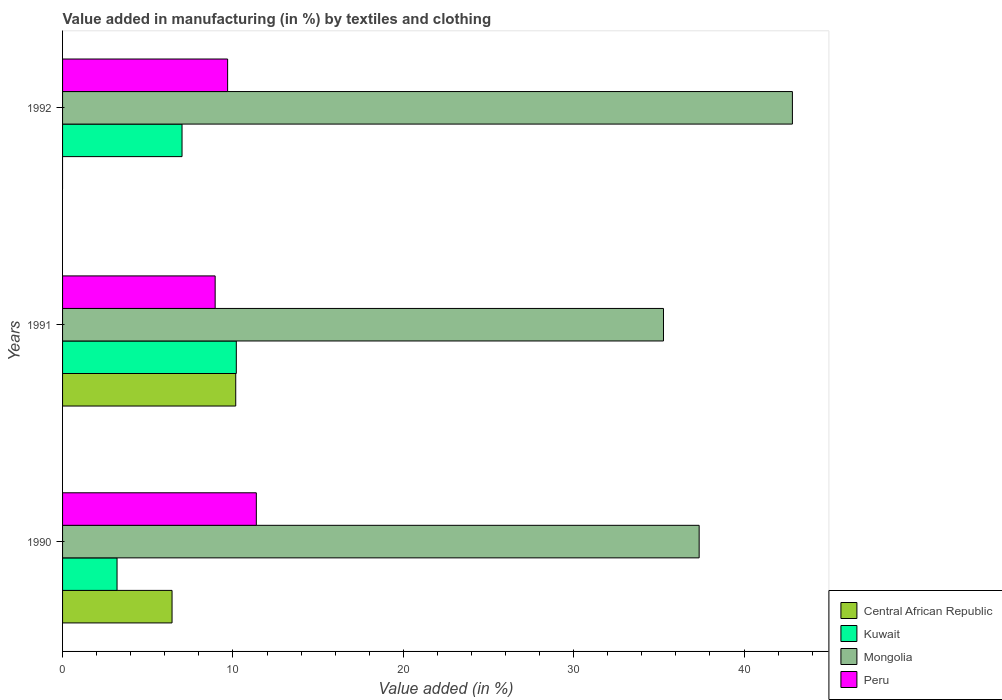How many groups of bars are there?
Your response must be concise. 3. Are the number of bars per tick equal to the number of legend labels?
Keep it short and to the point. No. How many bars are there on the 3rd tick from the bottom?
Ensure brevity in your answer.  3. What is the label of the 1st group of bars from the top?
Offer a terse response. 1992. In how many cases, is the number of bars for a given year not equal to the number of legend labels?
Make the answer very short. 1. What is the percentage of value added in manufacturing by textiles and clothing in Kuwait in 1990?
Provide a short and direct response. 3.2. Across all years, what is the maximum percentage of value added in manufacturing by textiles and clothing in Mongolia?
Offer a very short reply. 42.84. Across all years, what is the minimum percentage of value added in manufacturing by textiles and clothing in Central African Republic?
Your answer should be very brief. 0. In which year was the percentage of value added in manufacturing by textiles and clothing in Kuwait maximum?
Provide a short and direct response. 1991. What is the total percentage of value added in manufacturing by textiles and clothing in Peru in the graph?
Provide a short and direct response. 30.02. What is the difference between the percentage of value added in manufacturing by textiles and clothing in Peru in 1990 and that in 1991?
Offer a terse response. 2.42. What is the difference between the percentage of value added in manufacturing by textiles and clothing in Mongolia in 1992 and the percentage of value added in manufacturing by textiles and clothing in Central African Republic in 1991?
Your answer should be compact. 32.68. What is the average percentage of value added in manufacturing by textiles and clothing in Mongolia per year?
Provide a short and direct response. 38.49. In the year 1990, what is the difference between the percentage of value added in manufacturing by textiles and clothing in Central African Republic and percentage of value added in manufacturing by textiles and clothing in Kuwait?
Your response must be concise. 3.23. What is the ratio of the percentage of value added in manufacturing by textiles and clothing in Peru in 1991 to that in 1992?
Provide a short and direct response. 0.92. Is the percentage of value added in manufacturing by textiles and clothing in Peru in 1990 less than that in 1992?
Ensure brevity in your answer.  No. Is the difference between the percentage of value added in manufacturing by textiles and clothing in Central African Republic in 1990 and 1991 greater than the difference between the percentage of value added in manufacturing by textiles and clothing in Kuwait in 1990 and 1991?
Your response must be concise. Yes. What is the difference between the highest and the second highest percentage of value added in manufacturing by textiles and clothing in Kuwait?
Your answer should be very brief. 3.19. What is the difference between the highest and the lowest percentage of value added in manufacturing by textiles and clothing in Kuwait?
Make the answer very short. 7. In how many years, is the percentage of value added in manufacturing by textiles and clothing in Mongolia greater than the average percentage of value added in manufacturing by textiles and clothing in Mongolia taken over all years?
Make the answer very short. 1. How many bars are there?
Offer a terse response. 11. How many years are there in the graph?
Your answer should be very brief. 3. What is the difference between two consecutive major ticks on the X-axis?
Give a very brief answer. 10. Does the graph contain grids?
Make the answer very short. No. What is the title of the graph?
Give a very brief answer. Value added in manufacturing (in %) by textiles and clothing. Does "Tanzania" appear as one of the legend labels in the graph?
Make the answer very short. No. What is the label or title of the X-axis?
Offer a terse response. Value added (in %). What is the label or title of the Y-axis?
Ensure brevity in your answer.  Years. What is the Value added (in %) in Central African Republic in 1990?
Ensure brevity in your answer.  6.43. What is the Value added (in %) of Kuwait in 1990?
Your answer should be compact. 3.2. What is the Value added (in %) in Mongolia in 1990?
Your response must be concise. 37.37. What is the Value added (in %) in Peru in 1990?
Make the answer very short. 11.37. What is the Value added (in %) of Central African Republic in 1991?
Provide a succinct answer. 10.16. What is the Value added (in %) in Kuwait in 1991?
Offer a terse response. 10.2. What is the Value added (in %) of Mongolia in 1991?
Make the answer very short. 35.27. What is the Value added (in %) in Peru in 1991?
Your answer should be very brief. 8.96. What is the Value added (in %) of Central African Republic in 1992?
Your answer should be compact. 0. What is the Value added (in %) in Kuwait in 1992?
Your response must be concise. 7.01. What is the Value added (in %) in Mongolia in 1992?
Give a very brief answer. 42.84. What is the Value added (in %) of Peru in 1992?
Provide a short and direct response. 9.69. Across all years, what is the maximum Value added (in %) of Central African Republic?
Your answer should be compact. 10.16. Across all years, what is the maximum Value added (in %) of Kuwait?
Give a very brief answer. 10.2. Across all years, what is the maximum Value added (in %) of Mongolia?
Your response must be concise. 42.84. Across all years, what is the maximum Value added (in %) in Peru?
Your response must be concise. 11.37. Across all years, what is the minimum Value added (in %) of Central African Republic?
Your answer should be very brief. 0. Across all years, what is the minimum Value added (in %) in Kuwait?
Keep it short and to the point. 3.2. Across all years, what is the minimum Value added (in %) of Mongolia?
Give a very brief answer. 35.27. Across all years, what is the minimum Value added (in %) of Peru?
Offer a very short reply. 8.96. What is the total Value added (in %) in Central African Republic in the graph?
Offer a terse response. 16.59. What is the total Value added (in %) of Kuwait in the graph?
Provide a succinct answer. 20.41. What is the total Value added (in %) of Mongolia in the graph?
Keep it short and to the point. 115.48. What is the total Value added (in %) in Peru in the graph?
Ensure brevity in your answer.  30.02. What is the difference between the Value added (in %) of Central African Republic in 1990 and that in 1991?
Ensure brevity in your answer.  -3.74. What is the difference between the Value added (in %) of Kuwait in 1990 and that in 1991?
Your response must be concise. -7. What is the difference between the Value added (in %) of Mongolia in 1990 and that in 1991?
Ensure brevity in your answer.  2.09. What is the difference between the Value added (in %) of Peru in 1990 and that in 1991?
Provide a short and direct response. 2.42. What is the difference between the Value added (in %) in Kuwait in 1990 and that in 1992?
Offer a very short reply. -3.82. What is the difference between the Value added (in %) of Mongolia in 1990 and that in 1992?
Give a very brief answer. -5.47. What is the difference between the Value added (in %) in Peru in 1990 and that in 1992?
Give a very brief answer. 1.68. What is the difference between the Value added (in %) of Kuwait in 1991 and that in 1992?
Your answer should be compact. 3.19. What is the difference between the Value added (in %) in Mongolia in 1991 and that in 1992?
Make the answer very short. -7.57. What is the difference between the Value added (in %) of Peru in 1991 and that in 1992?
Keep it short and to the point. -0.73. What is the difference between the Value added (in %) in Central African Republic in 1990 and the Value added (in %) in Kuwait in 1991?
Offer a terse response. -3.77. What is the difference between the Value added (in %) of Central African Republic in 1990 and the Value added (in %) of Mongolia in 1991?
Keep it short and to the point. -28.85. What is the difference between the Value added (in %) of Central African Republic in 1990 and the Value added (in %) of Peru in 1991?
Your answer should be very brief. -2.53. What is the difference between the Value added (in %) of Kuwait in 1990 and the Value added (in %) of Mongolia in 1991?
Make the answer very short. -32.08. What is the difference between the Value added (in %) in Kuwait in 1990 and the Value added (in %) in Peru in 1991?
Your answer should be very brief. -5.76. What is the difference between the Value added (in %) of Mongolia in 1990 and the Value added (in %) of Peru in 1991?
Provide a short and direct response. 28.41. What is the difference between the Value added (in %) of Central African Republic in 1990 and the Value added (in %) of Kuwait in 1992?
Provide a succinct answer. -0.59. What is the difference between the Value added (in %) of Central African Republic in 1990 and the Value added (in %) of Mongolia in 1992?
Keep it short and to the point. -36.41. What is the difference between the Value added (in %) of Central African Republic in 1990 and the Value added (in %) of Peru in 1992?
Ensure brevity in your answer.  -3.26. What is the difference between the Value added (in %) of Kuwait in 1990 and the Value added (in %) of Mongolia in 1992?
Offer a very short reply. -39.64. What is the difference between the Value added (in %) of Kuwait in 1990 and the Value added (in %) of Peru in 1992?
Provide a succinct answer. -6.49. What is the difference between the Value added (in %) of Mongolia in 1990 and the Value added (in %) of Peru in 1992?
Keep it short and to the point. 27.68. What is the difference between the Value added (in %) in Central African Republic in 1991 and the Value added (in %) in Kuwait in 1992?
Give a very brief answer. 3.15. What is the difference between the Value added (in %) in Central African Republic in 1991 and the Value added (in %) in Mongolia in 1992?
Provide a succinct answer. -32.68. What is the difference between the Value added (in %) in Central African Republic in 1991 and the Value added (in %) in Peru in 1992?
Give a very brief answer. 0.48. What is the difference between the Value added (in %) in Kuwait in 1991 and the Value added (in %) in Mongolia in 1992?
Keep it short and to the point. -32.64. What is the difference between the Value added (in %) in Kuwait in 1991 and the Value added (in %) in Peru in 1992?
Give a very brief answer. 0.51. What is the difference between the Value added (in %) of Mongolia in 1991 and the Value added (in %) of Peru in 1992?
Ensure brevity in your answer.  25.58. What is the average Value added (in %) in Central African Republic per year?
Your response must be concise. 5.53. What is the average Value added (in %) of Kuwait per year?
Ensure brevity in your answer.  6.8. What is the average Value added (in %) in Mongolia per year?
Make the answer very short. 38.49. What is the average Value added (in %) in Peru per year?
Offer a very short reply. 10.01. In the year 1990, what is the difference between the Value added (in %) in Central African Republic and Value added (in %) in Kuwait?
Your answer should be compact. 3.23. In the year 1990, what is the difference between the Value added (in %) in Central African Republic and Value added (in %) in Mongolia?
Offer a terse response. -30.94. In the year 1990, what is the difference between the Value added (in %) of Central African Republic and Value added (in %) of Peru?
Provide a succinct answer. -4.95. In the year 1990, what is the difference between the Value added (in %) of Kuwait and Value added (in %) of Mongolia?
Your answer should be compact. -34.17. In the year 1990, what is the difference between the Value added (in %) of Kuwait and Value added (in %) of Peru?
Your answer should be very brief. -8.18. In the year 1990, what is the difference between the Value added (in %) of Mongolia and Value added (in %) of Peru?
Make the answer very short. 25.99. In the year 1991, what is the difference between the Value added (in %) in Central African Republic and Value added (in %) in Kuwait?
Your response must be concise. -0.03. In the year 1991, what is the difference between the Value added (in %) of Central African Republic and Value added (in %) of Mongolia?
Provide a succinct answer. -25.11. In the year 1991, what is the difference between the Value added (in %) of Central African Republic and Value added (in %) of Peru?
Keep it short and to the point. 1.21. In the year 1991, what is the difference between the Value added (in %) of Kuwait and Value added (in %) of Mongolia?
Provide a succinct answer. -25.07. In the year 1991, what is the difference between the Value added (in %) of Kuwait and Value added (in %) of Peru?
Your response must be concise. 1.24. In the year 1991, what is the difference between the Value added (in %) in Mongolia and Value added (in %) in Peru?
Offer a terse response. 26.32. In the year 1992, what is the difference between the Value added (in %) of Kuwait and Value added (in %) of Mongolia?
Offer a terse response. -35.83. In the year 1992, what is the difference between the Value added (in %) of Kuwait and Value added (in %) of Peru?
Ensure brevity in your answer.  -2.68. In the year 1992, what is the difference between the Value added (in %) of Mongolia and Value added (in %) of Peru?
Your answer should be very brief. 33.15. What is the ratio of the Value added (in %) of Central African Republic in 1990 to that in 1991?
Provide a short and direct response. 0.63. What is the ratio of the Value added (in %) of Kuwait in 1990 to that in 1991?
Provide a succinct answer. 0.31. What is the ratio of the Value added (in %) of Mongolia in 1990 to that in 1991?
Give a very brief answer. 1.06. What is the ratio of the Value added (in %) in Peru in 1990 to that in 1991?
Your response must be concise. 1.27. What is the ratio of the Value added (in %) in Kuwait in 1990 to that in 1992?
Your response must be concise. 0.46. What is the ratio of the Value added (in %) of Mongolia in 1990 to that in 1992?
Offer a very short reply. 0.87. What is the ratio of the Value added (in %) in Peru in 1990 to that in 1992?
Give a very brief answer. 1.17. What is the ratio of the Value added (in %) of Kuwait in 1991 to that in 1992?
Offer a very short reply. 1.45. What is the ratio of the Value added (in %) in Mongolia in 1991 to that in 1992?
Provide a short and direct response. 0.82. What is the ratio of the Value added (in %) of Peru in 1991 to that in 1992?
Offer a very short reply. 0.92. What is the difference between the highest and the second highest Value added (in %) in Kuwait?
Provide a short and direct response. 3.19. What is the difference between the highest and the second highest Value added (in %) in Mongolia?
Your answer should be compact. 5.47. What is the difference between the highest and the second highest Value added (in %) of Peru?
Make the answer very short. 1.68. What is the difference between the highest and the lowest Value added (in %) of Central African Republic?
Offer a terse response. 10.16. What is the difference between the highest and the lowest Value added (in %) in Kuwait?
Your answer should be compact. 7. What is the difference between the highest and the lowest Value added (in %) of Mongolia?
Ensure brevity in your answer.  7.57. What is the difference between the highest and the lowest Value added (in %) in Peru?
Offer a terse response. 2.42. 